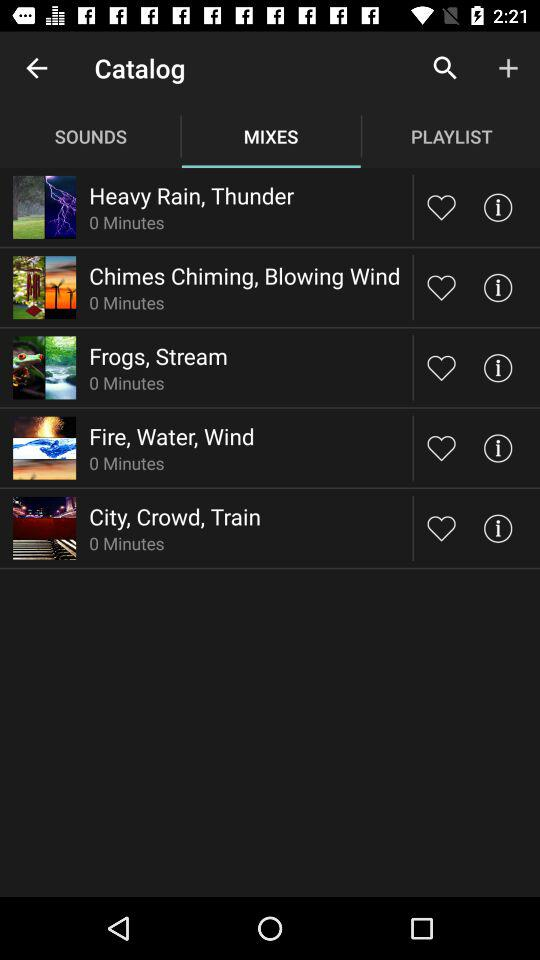What is the duration of the audio "Frogs, Stream"? The duration of the audio "Frogs, Stream" is 0 minutes. 